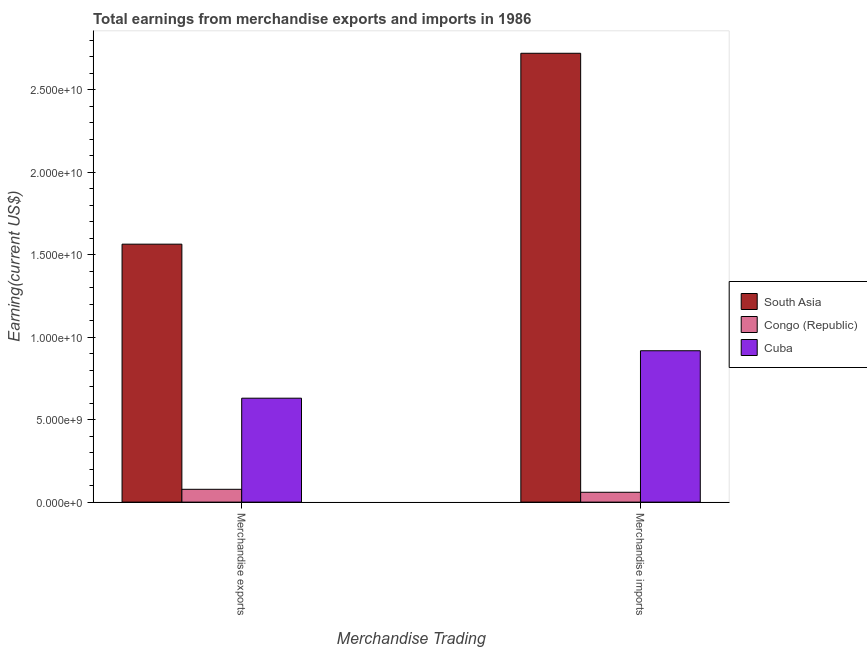How many different coloured bars are there?
Provide a succinct answer. 3. How many groups of bars are there?
Offer a terse response. 2. What is the label of the 2nd group of bars from the left?
Keep it short and to the point. Merchandise imports. What is the earnings from merchandise exports in Congo (Republic)?
Offer a very short reply. 7.77e+08. Across all countries, what is the maximum earnings from merchandise imports?
Give a very brief answer. 2.72e+1. Across all countries, what is the minimum earnings from merchandise imports?
Keep it short and to the point. 5.97e+08. In which country was the earnings from merchandise exports minimum?
Your answer should be very brief. Congo (Republic). What is the total earnings from merchandise exports in the graph?
Your answer should be compact. 2.27e+1. What is the difference between the earnings from merchandise imports in Cuba and that in Congo (Republic)?
Provide a short and direct response. 8.58e+09. What is the difference between the earnings from merchandise imports in Cuba and the earnings from merchandise exports in Congo (Republic)?
Provide a short and direct response. 8.40e+09. What is the average earnings from merchandise exports per country?
Your answer should be compact. 7.57e+09. What is the difference between the earnings from merchandise imports and earnings from merchandise exports in Congo (Republic)?
Offer a terse response. -1.80e+08. What is the ratio of the earnings from merchandise imports in Congo (Republic) to that in Cuba?
Provide a succinct answer. 0.07. In how many countries, is the earnings from merchandise imports greater than the average earnings from merchandise imports taken over all countries?
Provide a short and direct response. 1. What does the 1st bar from the left in Merchandise imports represents?
Your answer should be compact. South Asia. What does the 1st bar from the right in Merchandise imports represents?
Give a very brief answer. Cuba. How many bars are there?
Give a very brief answer. 6. Are all the bars in the graph horizontal?
Provide a short and direct response. No. What is the difference between two consecutive major ticks on the Y-axis?
Keep it short and to the point. 5.00e+09. How are the legend labels stacked?
Keep it short and to the point. Vertical. What is the title of the graph?
Your response must be concise. Total earnings from merchandise exports and imports in 1986. Does "San Marino" appear as one of the legend labels in the graph?
Offer a terse response. No. What is the label or title of the X-axis?
Make the answer very short. Merchandise Trading. What is the label or title of the Y-axis?
Provide a succinct answer. Earning(current US$). What is the Earning(current US$) of South Asia in Merchandise exports?
Offer a very short reply. 1.56e+1. What is the Earning(current US$) of Congo (Republic) in Merchandise exports?
Your answer should be compact. 7.77e+08. What is the Earning(current US$) in Cuba in Merchandise exports?
Your response must be concise. 6.30e+09. What is the Earning(current US$) in South Asia in Merchandise imports?
Your response must be concise. 2.72e+1. What is the Earning(current US$) in Congo (Republic) in Merchandise imports?
Offer a very short reply. 5.97e+08. What is the Earning(current US$) of Cuba in Merchandise imports?
Keep it short and to the point. 9.17e+09. Across all Merchandise Trading, what is the maximum Earning(current US$) in South Asia?
Offer a terse response. 2.72e+1. Across all Merchandise Trading, what is the maximum Earning(current US$) of Congo (Republic)?
Offer a very short reply. 7.77e+08. Across all Merchandise Trading, what is the maximum Earning(current US$) in Cuba?
Offer a terse response. 9.17e+09. Across all Merchandise Trading, what is the minimum Earning(current US$) in South Asia?
Make the answer very short. 1.56e+1. Across all Merchandise Trading, what is the minimum Earning(current US$) of Congo (Republic)?
Give a very brief answer. 5.97e+08. Across all Merchandise Trading, what is the minimum Earning(current US$) in Cuba?
Keep it short and to the point. 6.30e+09. What is the total Earning(current US$) in South Asia in the graph?
Give a very brief answer. 4.28e+1. What is the total Earning(current US$) of Congo (Republic) in the graph?
Your response must be concise. 1.37e+09. What is the total Earning(current US$) of Cuba in the graph?
Your answer should be compact. 1.55e+1. What is the difference between the Earning(current US$) in South Asia in Merchandise exports and that in Merchandise imports?
Ensure brevity in your answer.  -1.16e+1. What is the difference between the Earning(current US$) of Congo (Republic) in Merchandise exports and that in Merchandise imports?
Ensure brevity in your answer.  1.80e+08. What is the difference between the Earning(current US$) in Cuba in Merchandise exports and that in Merchandise imports?
Provide a succinct answer. -2.88e+09. What is the difference between the Earning(current US$) in South Asia in Merchandise exports and the Earning(current US$) in Congo (Republic) in Merchandise imports?
Offer a terse response. 1.50e+1. What is the difference between the Earning(current US$) in South Asia in Merchandise exports and the Earning(current US$) in Cuba in Merchandise imports?
Provide a succinct answer. 6.46e+09. What is the difference between the Earning(current US$) of Congo (Republic) in Merchandise exports and the Earning(current US$) of Cuba in Merchandise imports?
Give a very brief answer. -8.40e+09. What is the average Earning(current US$) of South Asia per Merchandise Trading?
Make the answer very short. 2.14e+1. What is the average Earning(current US$) of Congo (Republic) per Merchandise Trading?
Make the answer very short. 6.87e+08. What is the average Earning(current US$) in Cuba per Merchandise Trading?
Provide a short and direct response. 7.74e+09. What is the difference between the Earning(current US$) of South Asia and Earning(current US$) of Congo (Republic) in Merchandise exports?
Provide a succinct answer. 1.49e+1. What is the difference between the Earning(current US$) in South Asia and Earning(current US$) in Cuba in Merchandise exports?
Keep it short and to the point. 9.33e+09. What is the difference between the Earning(current US$) in Congo (Republic) and Earning(current US$) in Cuba in Merchandise exports?
Provide a short and direct response. -5.52e+09. What is the difference between the Earning(current US$) in South Asia and Earning(current US$) in Congo (Republic) in Merchandise imports?
Your answer should be compact. 2.66e+1. What is the difference between the Earning(current US$) of South Asia and Earning(current US$) of Cuba in Merchandise imports?
Provide a short and direct response. 1.80e+1. What is the difference between the Earning(current US$) in Congo (Republic) and Earning(current US$) in Cuba in Merchandise imports?
Keep it short and to the point. -8.58e+09. What is the ratio of the Earning(current US$) of South Asia in Merchandise exports to that in Merchandise imports?
Your answer should be compact. 0.57. What is the ratio of the Earning(current US$) of Congo (Republic) in Merchandise exports to that in Merchandise imports?
Keep it short and to the point. 1.3. What is the ratio of the Earning(current US$) of Cuba in Merchandise exports to that in Merchandise imports?
Offer a terse response. 0.69. What is the difference between the highest and the second highest Earning(current US$) in South Asia?
Your answer should be compact. 1.16e+1. What is the difference between the highest and the second highest Earning(current US$) in Congo (Republic)?
Your answer should be very brief. 1.80e+08. What is the difference between the highest and the second highest Earning(current US$) in Cuba?
Offer a very short reply. 2.88e+09. What is the difference between the highest and the lowest Earning(current US$) of South Asia?
Make the answer very short. 1.16e+1. What is the difference between the highest and the lowest Earning(current US$) of Congo (Republic)?
Your answer should be compact. 1.80e+08. What is the difference between the highest and the lowest Earning(current US$) in Cuba?
Your answer should be very brief. 2.88e+09. 